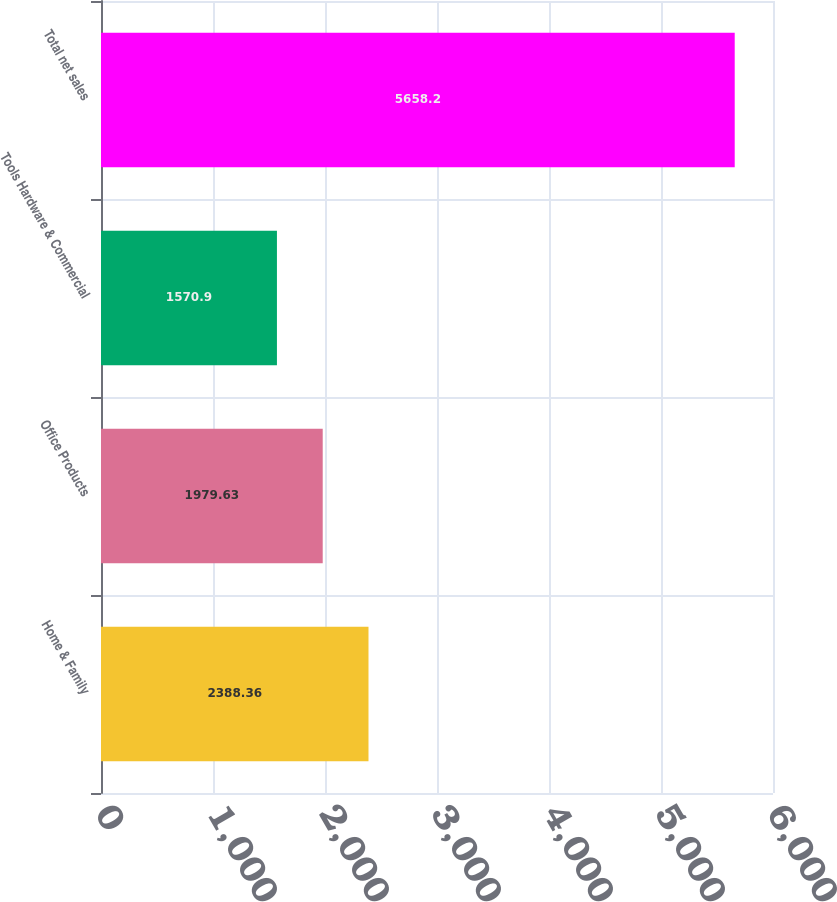Convert chart to OTSL. <chart><loc_0><loc_0><loc_500><loc_500><bar_chart><fcel>Home & Family<fcel>Office Products<fcel>Tools Hardware & Commercial<fcel>Total net sales<nl><fcel>2388.36<fcel>1979.63<fcel>1570.9<fcel>5658.2<nl></chart> 